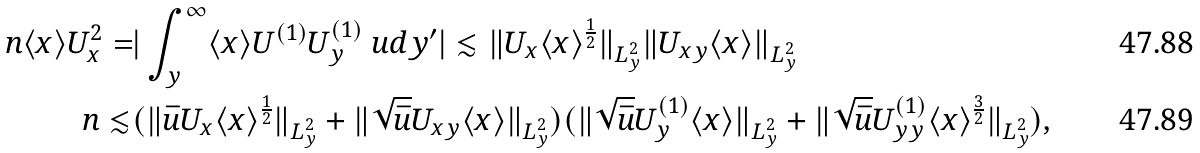Convert formula to latex. <formula><loc_0><loc_0><loc_500><loc_500>\ n \langle x \rangle U _ { x } ^ { 2 } = & | \int _ { y } ^ { \infty } \langle x \rangle U ^ { ( 1 ) } U ^ { ( 1 ) } _ { y } \ u d y ^ { \prime } | \lesssim \| U _ { x } \langle x \rangle ^ { \frac { 1 } { 2 } } \| _ { L ^ { 2 } _ { y } } \| U _ { x y } \langle x \rangle \| _ { L ^ { 2 } _ { y } } \\ \ n \lesssim & ( \| \bar { u } U _ { x } \langle x \rangle ^ { \frac { 1 } { 2 } } \| _ { L ^ { 2 } _ { y } } + \| \sqrt { \bar { u } } U _ { x y } \langle x \rangle \| _ { L ^ { 2 } _ { y } } ) ( \| \sqrt { \bar { u } } U ^ { ( 1 ) } _ { y } \langle x \rangle \| _ { L ^ { 2 } _ { y } } + \| \sqrt { \bar { u } } U ^ { ( 1 ) } _ { y y } \langle x \rangle ^ { \frac { 3 } { 2 } } \| _ { L ^ { 2 } _ { y } } ) ,</formula> 